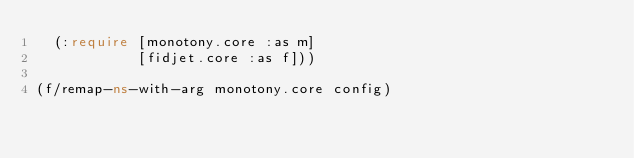Convert code to text. <code><loc_0><loc_0><loc_500><loc_500><_Clojure_>  (:require [monotony.core :as m]
            [fidjet.core :as f]))

(f/remap-ns-with-arg monotony.core config)
</code> 